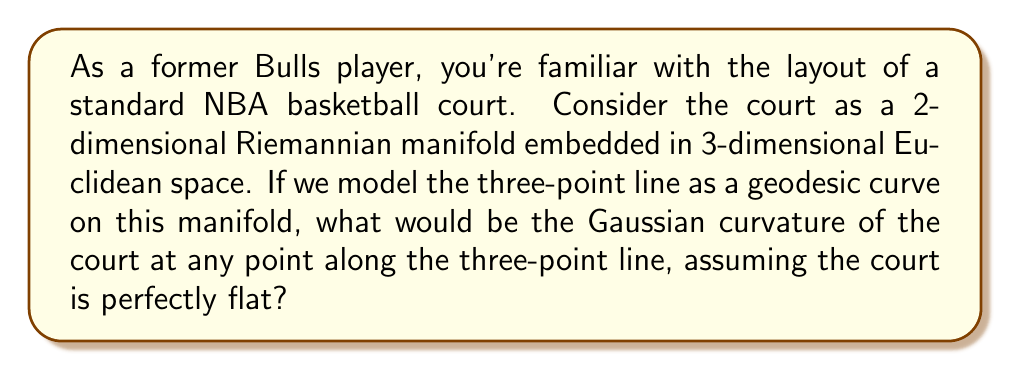Could you help me with this problem? To approach this problem, let's break it down step-by-step:

1) First, recall that a Riemannian manifold is a smooth manifold equipped with a Riemannian metric, which allows us to measure distances and angles on the manifold.

2) The basketball court, being a flat surface, can be modeled as a 2-dimensional Riemannian manifold embedded in 3-dimensional Euclidean space. This manifold is actually a subset of the Euclidean plane $\mathbb{R}^2$.

3) The three-point line on a basketball court is not a straight line; it's an arc of a circle at a set distance from the basket. However, in the context of the court as a Riemannian manifold, we're considering it as a geodesic curve.

4) In Riemannian geometry, geodesics are the generalization of straight lines to curved spaces. They represent the shortest path between two points on the manifold.

5) The Gaussian curvature of a surface at a point is a measure of how much the surface deviates from being flat at that point. It's defined as the product of the two principal curvatures at the point.

6) For a perfectly flat surface, like our idealized basketball court, the principal curvatures are both zero at every point.

7) The Gaussian curvature $K$ is given by:

   $$K = \kappa_1 \kappa_2$$

   where $\kappa_1$ and $\kappa_2$ are the principal curvatures.

8) Since both principal curvatures are zero for a flat surface, the Gaussian curvature at any point on the court, including along the three-point line, would be:

   $$K = 0 \cdot 0 = 0$$

Therefore, the Gaussian curvature of the court at any point along the three-point line (and indeed at any point on the court) is zero.
Answer: The Gaussian curvature of the court at any point along the three-point line is $0$. 